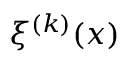<formula> <loc_0><loc_0><loc_500><loc_500>\xi ^ { ( k ) } ( x )</formula> 